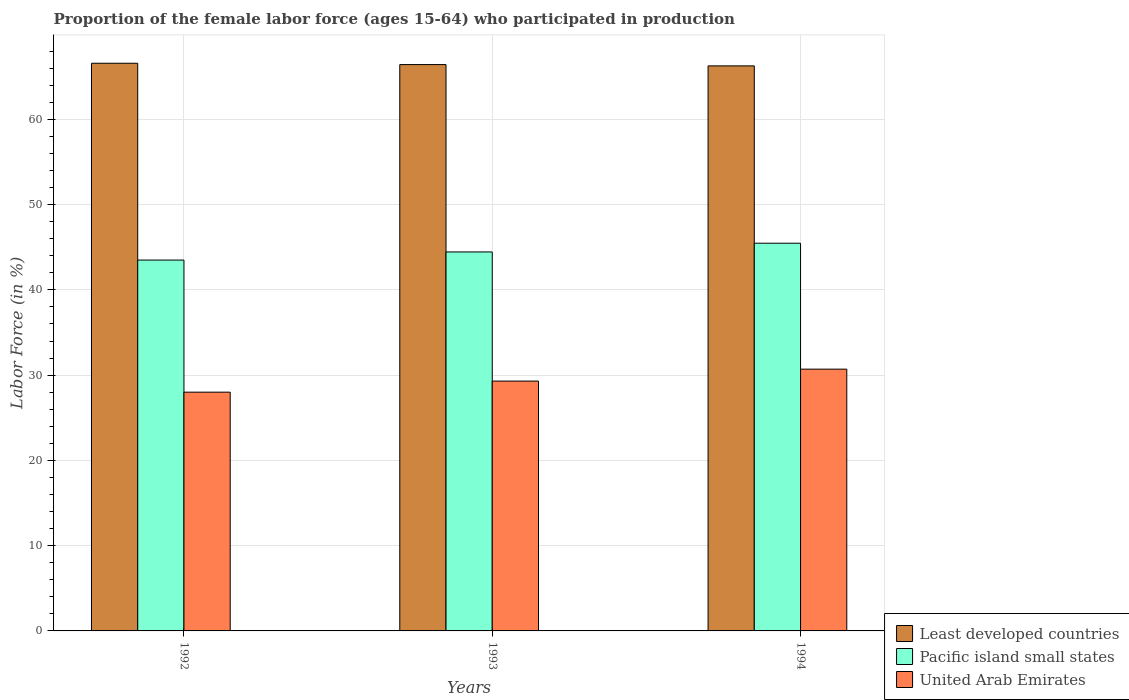How many different coloured bars are there?
Your response must be concise. 3. How many groups of bars are there?
Keep it short and to the point. 3. How many bars are there on the 3rd tick from the left?
Ensure brevity in your answer.  3. How many bars are there on the 1st tick from the right?
Give a very brief answer. 3. What is the label of the 1st group of bars from the left?
Ensure brevity in your answer.  1992. In how many cases, is the number of bars for a given year not equal to the number of legend labels?
Give a very brief answer. 0. What is the proportion of the female labor force who participated in production in Pacific island small states in 1994?
Provide a short and direct response. 45.47. Across all years, what is the maximum proportion of the female labor force who participated in production in United Arab Emirates?
Offer a very short reply. 30.7. Across all years, what is the minimum proportion of the female labor force who participated in production in Least developed countries?
Your answer should be very brief. 66.27. In which year was the proportion of the female labor force who participated in production in Pacific island small states maximum?
Provide a short and direct response. 1994. What is the total proportion of the female labor force who participated in production in Least developed countries in the graph?
Give a very brief answer. 199.26. What is the difference between the proportion of the female labor force who participated in production in Least developed countries in 1992 and that in 1994?
Provide a short and direct response. 0.31. What is the difference between the proportion of the female labor force who participated in production in Pacific island small states in 1993 and the proportion of the female labor force who participated in production in Least developed countries in 1994?
Your response must be concise. -21.82. What is the average proportion of the female labor force who participated in production in Least developed countries per year?
Make the answer very short. 66.42. In the year 1992, what is the difference between the proportion of the female labor force who participated in production in United Arab Emirates and proportion of the female labor force who participated in production in Least developed countries?
Offer a terse response. -38.57. In how many years, is the proportion of the female labor force who participated in production in Least developed countries greater than 44 %?
Keep it short and to the point. 3. What is the ratio of the proportion of the female labor force who participated in production in Least developed countries in 1992 to that in 1994?
Provide a short and direct response. 1. Is the difference between the proportion of the female labor force who participated in production in United Arab Emirates in 1992 and 1993 greater than the difference between the proportion of the female labor force who participated in production in Least developed countries in 1992 and 1993?
Your answer should be compact. No. What is the difference between the highest and the second highest proportion of the female labor force who participated in production in Pacific island small states?
Offer a very short reply. 1.02. What is the difference between the highest and the lowest proportion of the female labor force who participated in production in United Arab Emirates?
Your response must be concise. 2.7. In how many years, is the proportion of the female labor force who participated in production in Pacific island small states greater than the average proportion of the female labor force who participated in production in Pacific island small states taken over all years?
Your answer should be compact. 1. Is the sum of the proportion of the female labor force who participated in production in United Arab Emirates in 1992 and 1994 greater than the maximum proportion of the female labor force who participated in production in Pacific island small states across all years?
Your answer should be compact. Yes. What does the 2nd bar from the left in 1994 represents?
Offer a very short reply. Pacific island small states. What does the 2nd bar from the right in 1994 represents?
Your response must be concise. Pacific island small states. Is it the case that in every year, the sum of the proportion of the female labor force who participated in production in United Arab Emirates and proportion of the female labor force who participated in production in Pacific island small states is greater than the proportion of the female labor force who participated in production in Least developed countries?
Give a very brief answer. Yes. How many bars are there?
Provide a succinct answer. 9. Are all the bars in the graph horizontal?
Your response must be concise. No. How are the legend labels stacked?
Offer a very short reply. Vertical. What is the title of the graph?
Your response must be concise. Proportion of the female labor force (ages 15-64) who participated in production. Does "Malaysia" appear as one of the legend labels in the graph?
Provide a succinct answer. No. What is the label or title of the Y-axis?
Give a very brief answer. Labor Force (in %). What is the Labor Force (in %) of Least developed countries in 1992?
Make the answer very short. 66.57. What is the Labor Force (in %) in Pacific island small states in 1992?
Provide a short and direct response. 43.49. What is the Labor Force (in %) in United Arab Emirates in 1992?
Make the answer very short. 28. What is the Labor Force (in %) in Least developed countries in 1993?
Offer a terse response. 66.42. What is the Labor Force (in %) of Pacific island small states in 1993?
Provide a short and direct response. 44.44. What is the Labor Force (in %) in United Arab Emirates in 1993?
Make the answer very short. 29.3. What is the Labor Force (in %) of Least developed countries in 1994?
Make the answer very short. 66.27. What is the Labor Force (in %) of Pacific island small states in 1994?
Keep it short and to the point. 45.47. What is the Labor Force (in %) of United Arab Emirates in 1994?
Ensure brevity in your answer.  30.7. Across all years, what is the maximum Labor Force (in %) in Least developed countries?
Give a very brief answer. 66.57. Across all years, what is the maximum Labor Force (in %) of Pacific island small states?
Your response must be concise. 45.47. Across all years, what is the maximum Labor Force (in %) of United Arab Emirates?
Ensure brevity in your answer.  30.7. Across all years, what is the minimum Labor Force (in %) in Least developed countries?
Provide a short and direct response. 66.27. Across all years, what is the minimum Labor Force (in %) in Pacific island small states?
Make the answer very short. 43.49. Across all years, what is the minimum Labor Force (in %) in United Arab Emirates?
Your answer should be very brief. 28. What is the total Labor Force (in %) in Least developed countries in the graph?
Make the answer very short. 199.26. What is the total Labor Force (in %) in Pacific island small states in the graph?
Provide a succinct answer. 133.4. What is the difference between the Labor Force (in %) in Least developed countries in 1992 and that in 1993?
Give a very brief answer. 0.16. What is the difference between the Labor Force (in %) in Pacific island small states in 1992 and that in 1993?
Your answer should be compact. -0.95. What is the difference between the Labor Force (in %) of Least developed countries in 1992 and that in 1994?
Ensure brevity in your answer.  0.31. What is the difference between the Labor Force (in %) in Pacific island small states in 1992 and that in 1994?
Give a very brief answer. -1.98. What is the difference between the Labor Force (in %) of Least developed countries in 1993 and that in 1994?
Provide a succinct answer. 0.15. What is the difference between the Labor Force (in %) of Pacific island small states in 1993 and that in 1994?
Offer a terse response. -1.02. What is the difference between the Labor Force (in %) in Least developed countries in 1992 and the Labor Force (in %) in Pacific island small states in 1993?
Your answer should be very brief. 22.13. What is the difference between the Labor Force (in %) of Least developed countries in 1992 and the Labor Force (in %) of United Arab Emirates in 1993?
Your answer should be very brief. 37.27. What is the difference between the Labor Force (in %) in Pacific island small states in 1992 and the Labor Force (in %) in United Arab Emirates in 1993?
Your answer should be very brief. 14.19. What is the difference between the Labor Force (in %) in Least developed countries in 1992 and the Labor Force (in %) in Pacific island small states in 1994?
Offer a very short reply. 21.1. What is the difference between the Labor Force (in %) of Least developed countries in 1992 and the Labor Force (in %) of United Arab Emirates in 1994?
Make the answer very short. 35.87. What is the difference between the Labor Force (in %) of Pacific island small states in 1992 and the Labor Force (in %) of United Arab Emirates in 1994?
Ensure brevity in your answer.  12.79. What is the difference between the Labor Force (in %) of Least developed countries in 1993 and the Labor Force (in %) of Pacific island small states in 1994?
Give a very brief answer. 20.95. What is the difference between the Labor Force (in %) of Least developed countries in 1993 and the Labor Force (in %) of United Arab Emirates in 1994?
Provide a short and direct response. 35.72. What is the difference between the Labor Force (in %) in Pacific island small states in 1993 and the Labor Force (in %) in United Arab Emirates in 1994?
Ensure brevity in your answer.  13.74. What is the average Labor Force (in %) in Least developed countries per year?
Make the answer very short. 66.42. What is the average Labor Force (in %) of Pacific island small states per year?
Provide a succinct answer. 44.47. What is the average Labor Force (in %) in United Arab Emirates per year?
Offer a terse response. 29.33. In the year 1992, what is the difference between the Labor Force (in %) in Least developed countries and Labor Force (in %) in Pacific island small states?
Your answer should be very brief. 23.08. In the year 1992, what is the difference between the Labor Force (in %) in Least developed countries and Labor Force (in %) in United Arab Emirates?
Ensure brevity in your answer.  38.57. In the year 1992, what is the difference between the Labor Force (in %) of Pacific island small states and Labor Force (in %) of United Arab Emirates?
Make the answer very short. 15.49. In the year 1993, what is the difference between the Labor Force (in %) in Least developed countries and Labor Force (in %) in Pacific island small states?
Provide a succinct answer. 21.97. In the year 1993, what is the difference between the Labor Force (in %) of Least developed countries and Labor Force (in %) of United Arab Emirates?
Keep it short and to the point. 37.12. In the year 1993, what is the difference between the Labor Force (in %) of Pacific island small states and Labor Force (in %) of United Arab Emirates?
Make the answer very short. 15.14. In the year 1994, what is the difference between the Labor Force (in %) of Least developed countries and Labor Force (in %) of Pacific island small states?
Keep it short and to the point. 20.8. In the year 1994, what is the difference between the Labor Force (in %) in Least developed countries and Labor Force (in %) in United Arab Emirates?
Keep it short and to the point. 35.57. In the year 1994, what is the difference between the Labor Force (in %) in Pacific island small states and Labor Force (in %) in United Arab Emirates?
Your answer should be very brief. 14.77. What is the ratio of the Labor Force (in %) in Least developed countries in 1992 to that in 1993?
Keep it short and to the point. 1. What is the ratio of the Labor Force (in %) of Pacific island small states in 1992 to that in 1993?
Offer a terse response. 0.98. What is the ratio of the Labor Force (in %) in United Arab Emirates in 1992 to that in 1993?
Your answer should be very brief. 0.96. What is the ratio of the Labor Force (in %) in Least developed countries in 1992 to that in 1994?
Give a very brief answer. 1. What is the ratio of the Labor Force (in %) in Pacific island small states in 1992 to that in 1994?
Keep it short and to the point. 0.96. What is the ratio of the Labor Force (in %) of United Arab Emirates in 1992 to that in 1994?
Keep it short and to the point. 0.91. What is the ratio of the Labor Force (in %) of Least developed countries in 1993 to that in 1994?
Keep it short and to the point. 1. What is the ratio of the Labor Force (in %) of Pacific island small states in 1993 to that in 1994?
Your response must be concise. 0.98. What is the ratio of the Labor Force (in %) in United Arab Emirates in 1993 to that in 1994?
Give a very brief answer. 0.95. What is the difference between the highest and the second highest Labor Force (in %) of Least developed countries?
Provide a succinct answer. 0.16. What is the difference between the highest and the lowest Labor Force (in %) in Least developed countries?
Provide a succinct answer. 0.31. What is the difference between the highest and the lowest Labor Force (in %) in Pacific island small states?
Ensure brevity in your answer.  1.98. 